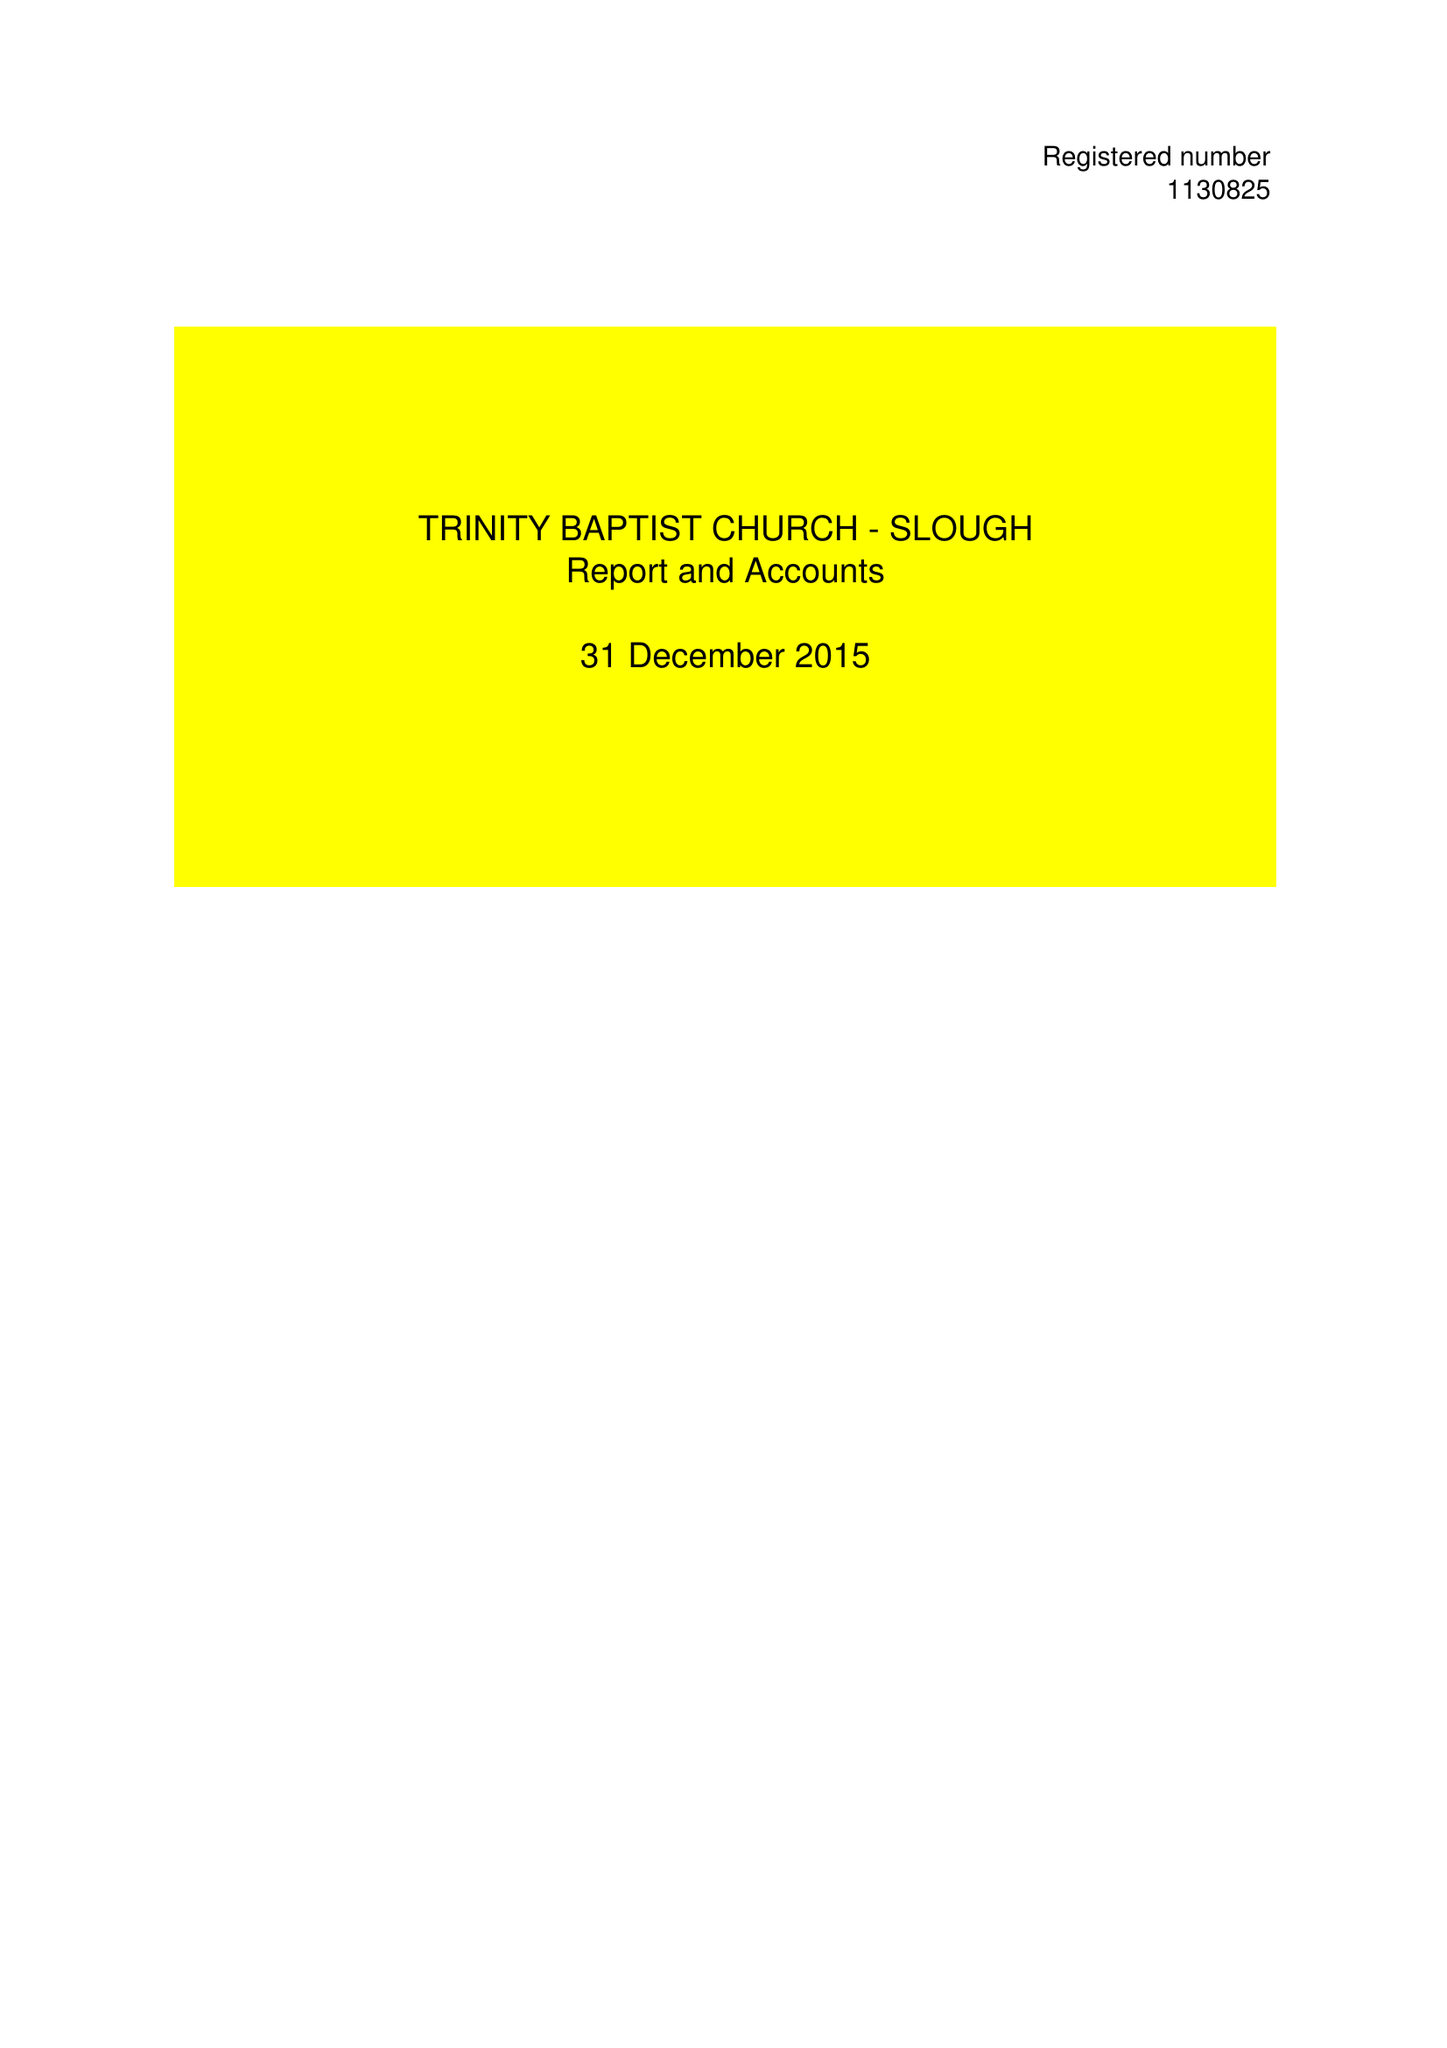What is the value for the charity_number?
Answer the question using a single word or phrase. 1130825 